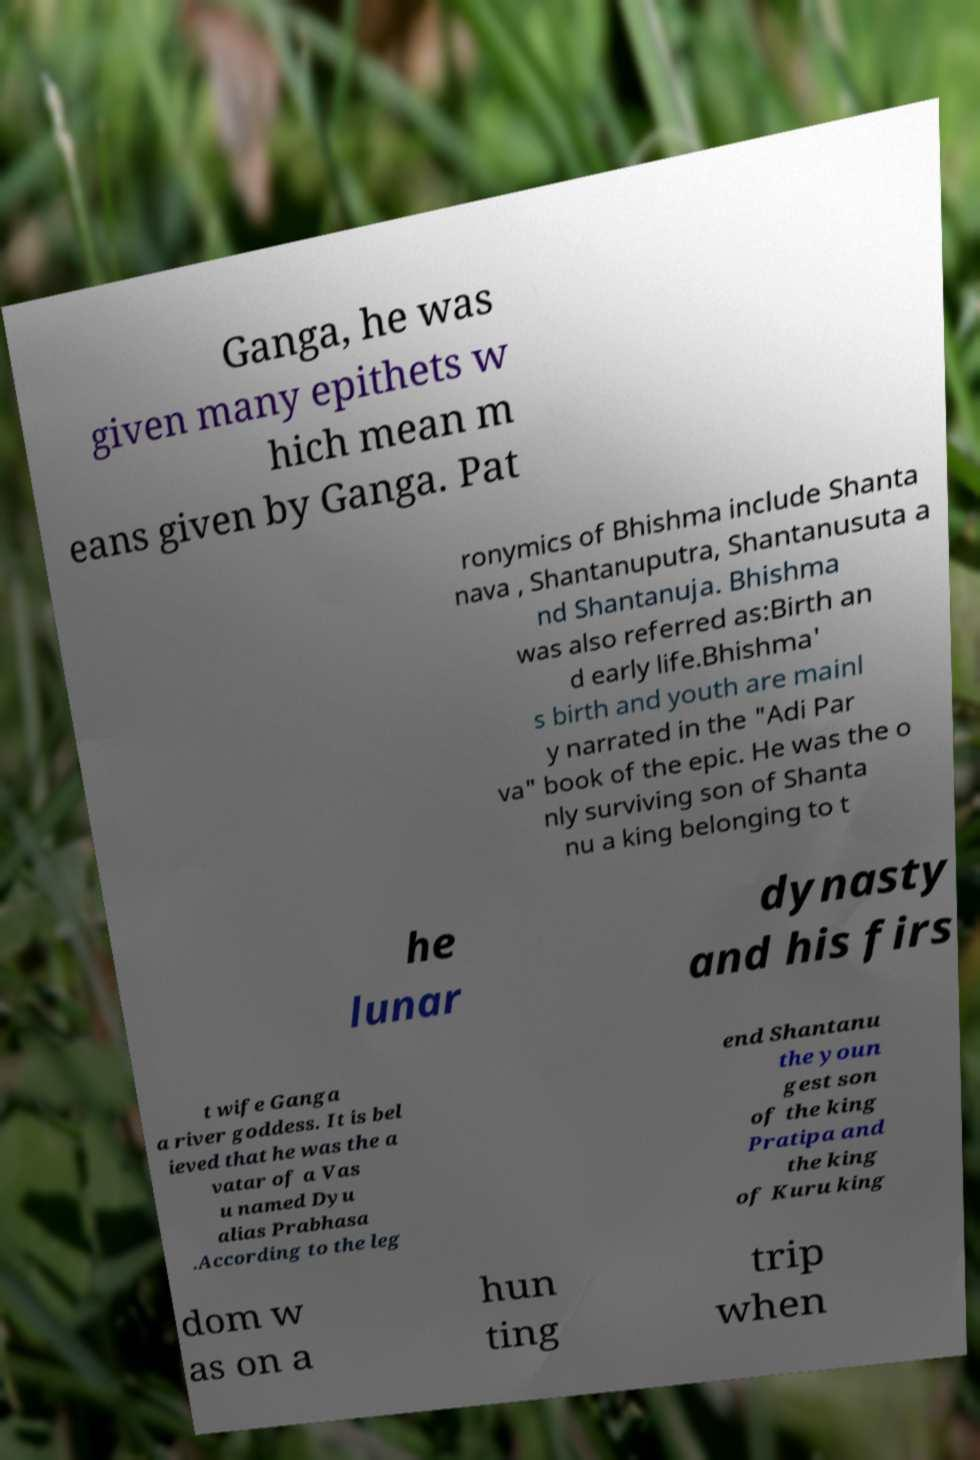Could you assist in decoding the text presented in this image and type it out clearly? Ganga, he was given many epithets w hich mean m eans given by Ganga. Pat ronymics of Bhishma include Shanta nava , Shantanuputra, Shantanusuta a nd Shantanuja. Bhishma was also referred as:Birth an d early life.Bhishma' s birth and youth are mainl y narrated in the "Adi Par va" book of the epic. He was the o nly surviving son of Shanta nu a king belonging to t he lunar dynasty and his firs t wife Ganga a river goddess. It is bel ieved that he was the a vatar of a Vas u named Dyu alias Prabhasa .According to the leg end Shantanu the youn gest son of the king Pratipa and the king of Kuru king dom w as on a hun ting trip when 